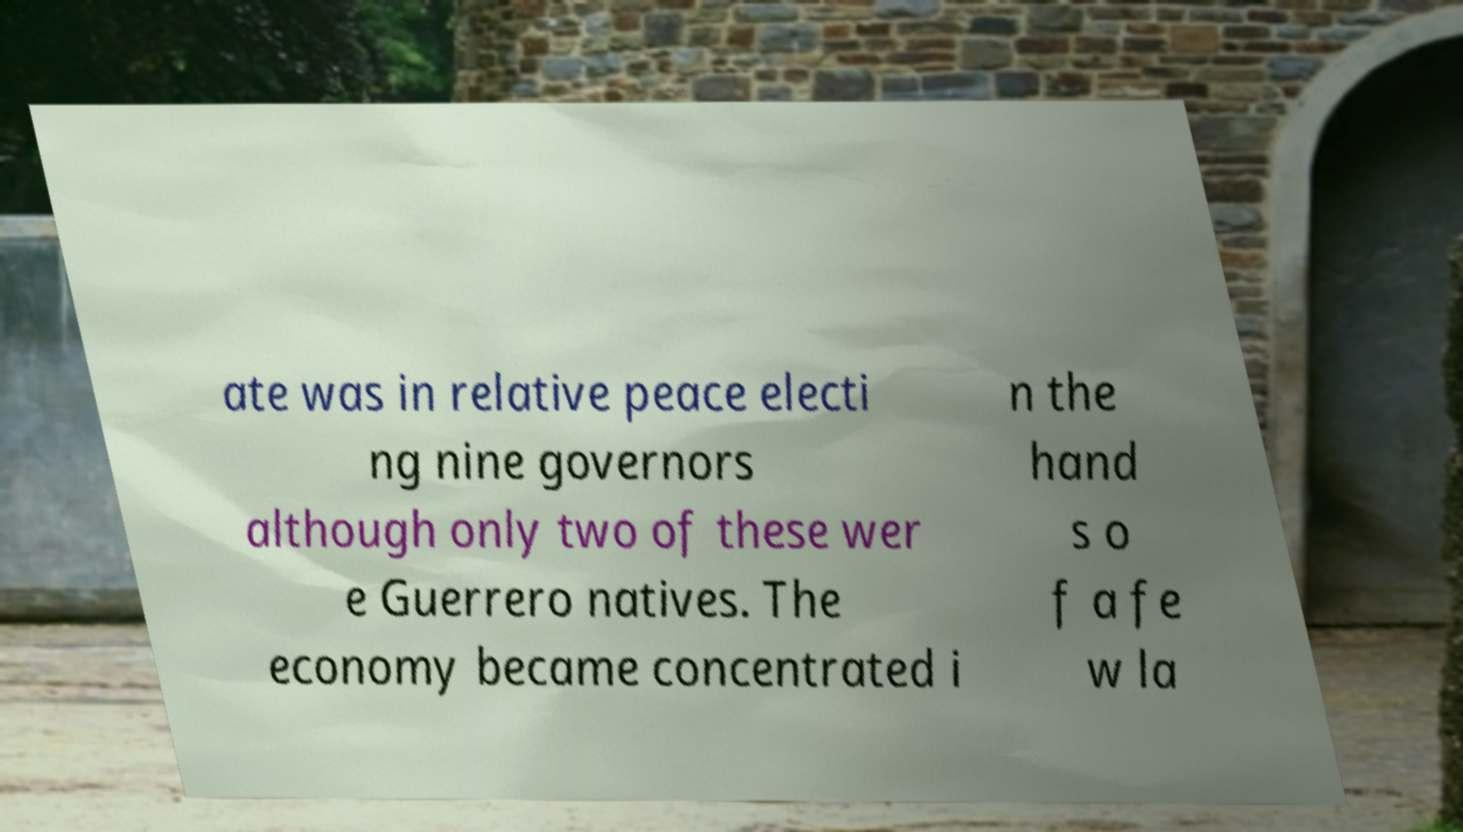Please read and relay the text visible in this image. What does it say? ate was in relative peace electi ng nine governors although only two of these wer e Guerrero natives. The economy became concentrated i n the hand s o f a fe w la 